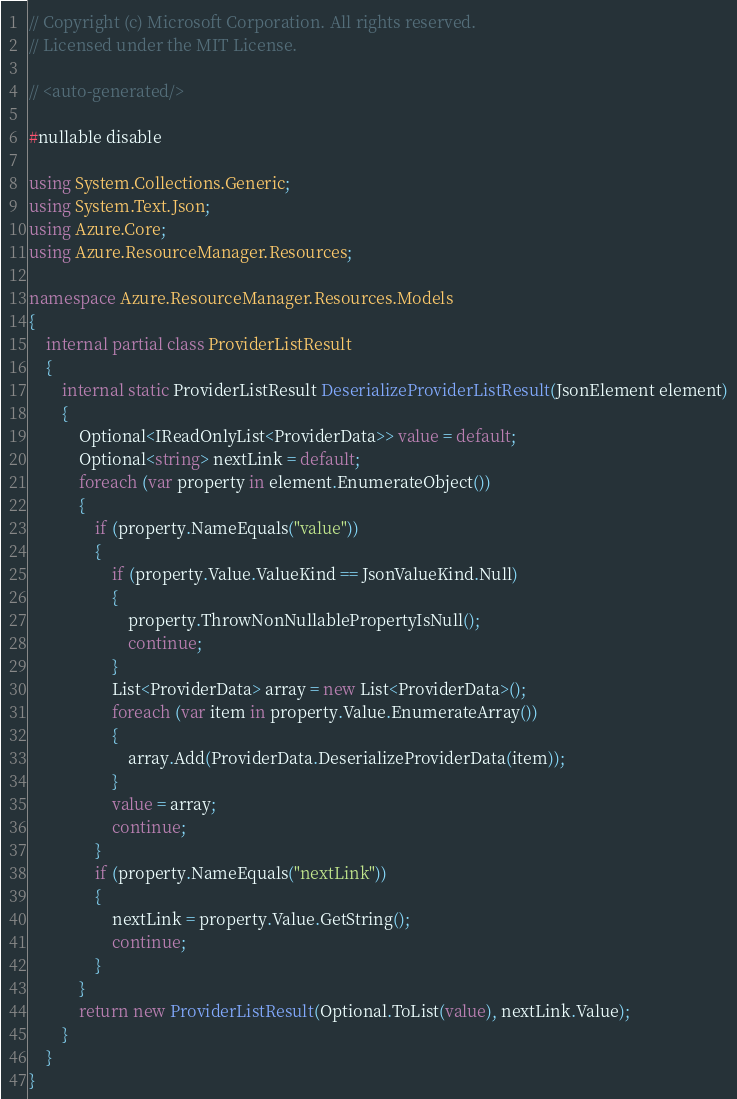<code> <loc_0><loc_0><loc_500><loc_500><_C#_>// Copyright (c) Microsoft Corporation. All rights reserved.
// Licensed under the MIT License.

// <auto-generated/>

#nullable disable

using System.Collections.Generic;
using System.Text.Json;
using Azure.Core;
using Azure.ResourceManager.Resources;

namespace Azure.ResourceManager.Resources.Models
{
    internal partial class ProviderListResult
    {
        internal static ProviderListResult DeserializeProviderListResult(JsonElement element)
        {
            Optional<IReadOnlyList<ProviderData>> value = default;
            Optional<string> nextLink = default;
            foreach (var property in element.EnumerateObject())
            {
                if (property.NameEquals("value"))
                {
                    if (property.Value.ValueKind == JsonValueKind.Null)
                    {
                        property.ThrowNonNullablePropertyIsNull();
                        continue;
                    }
                    List<ProviderData> array = new List<ProviderData>();
                    foreach (var item in property.Value.EnumerateArray())
                    {
                        array.Add(ProviderData.DeserializeProviderData(item));
                    }
                    value = array;
                    continue;
                }
                if (property.NameEquals("nextLink"))
                {
                    nextLink = property.Value.GetString();
                    continue;
                }
            }
            return new ProviderListResult(Optional.ToList(value), nextLink.Value);
        }
    }
}
</code> 